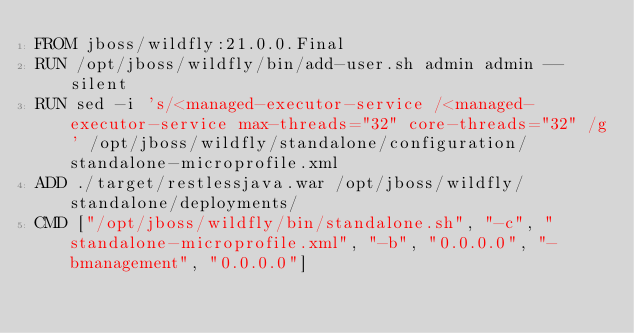<code> <loc_0><loc_0><loc_500><loc_500><_Dockerfile_>FROM jboss/wildfly:21.0.0.Final
RUN /opt/jboss/wildfly/bin/add-user.sh admin admin --silent
RUN sed -i 's/<managed-executor-service /<managed-executor-service max-threads="32" core-threads="32" /g' /opt/jboss/wildfly/standalone/configuration/standalone-microprofile.xml
ADD ./target/restlessjava.war /opt/jboss/wildfly/standalone/deployments/
CMD ["/opt/jboss/wildfly/bin/standalone.sh", "-c", "standalone-microprofile.xml", "-b", "0.0.0.0", "-bmanagement", "0.0.0.0"]
</code> 